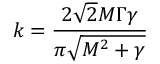Convert formula to latex. <formula><loc_0><loc_0><loc_500><loc_500>k = { \frac { 2 { \sqrt { 2 } } M \Gamma \gamma } { \pi { \sqrt { M ^ { 2 } + \gamma } } } }</formula> 